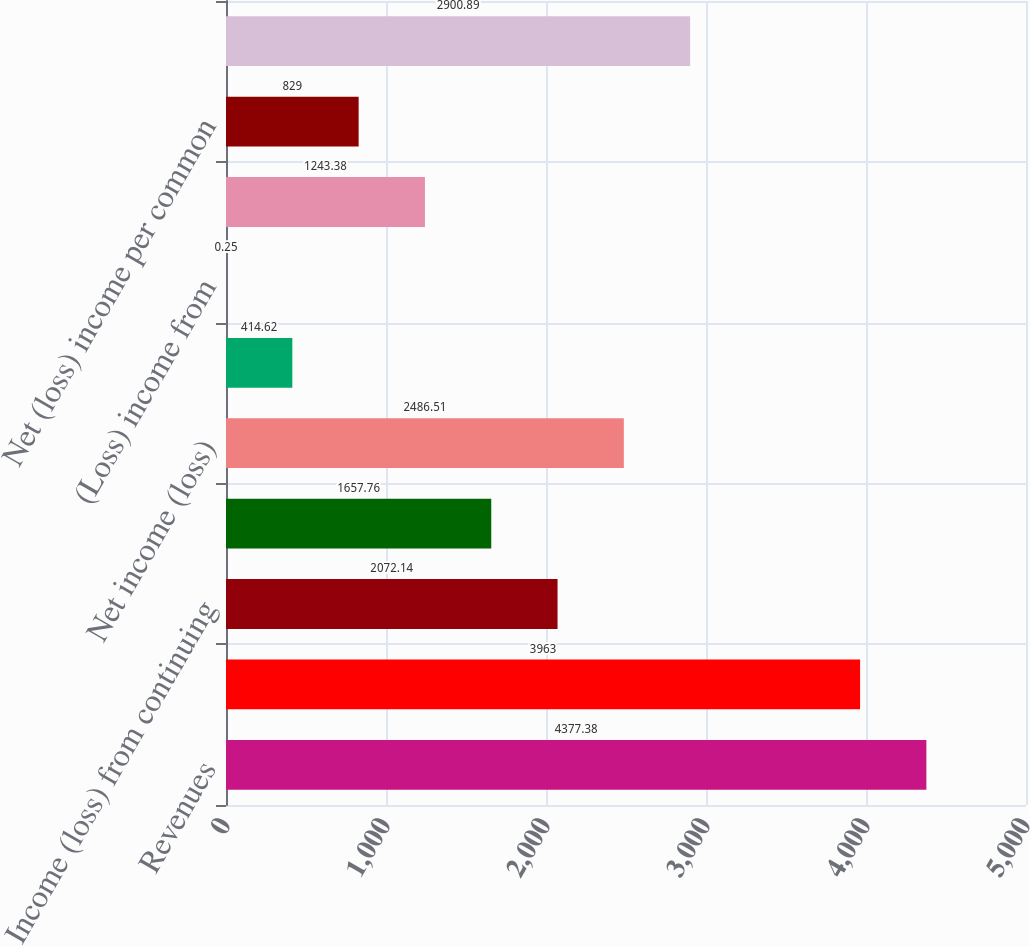Convert chart to OTSL. <chart><loc_0><loc_0><loc_500><loc_500><bar_chart><fcel>Revenues<fcel>Benefits losses and expenses<fcel>Income (loss) from continuing<fcel>Income from discontinued<fcel>Net income (loss)<fcel>(Loss) income from continuing<fcel>(Loss) income from<fcel>Net income per common share<fcel>Net (loss) income per common<fcel>Weighted average common shares<nl><fcel>4377.38<fcel>3963<fcel>2072.14<fcel>1657.76<fcel>2486.51<fcel>414.62<fcel>0.25<fcel>1243.38<fcel>829<fcel>2900.89<nl></chart> 